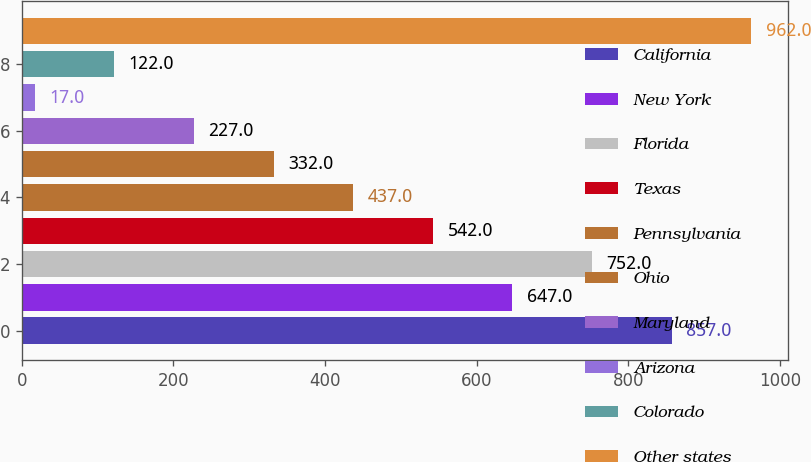<chart> <loc_0><loc_0><loc_500><loc_500><bar_chart><fcel>California<fcel>New York<fcel>Florida<fcel>Texas<fcel>Pennsylvania<fcel>Ohio<fcel>Maryland<fcel>Arizona<fcel>Colorado<fcel>Other states<nl><fcel>857<fcel>647<fcel>752<fcel>542<fcel>437<fcel>332<fcel>227<fcel>17<fcel>122<fcel>962<nl></chart> 